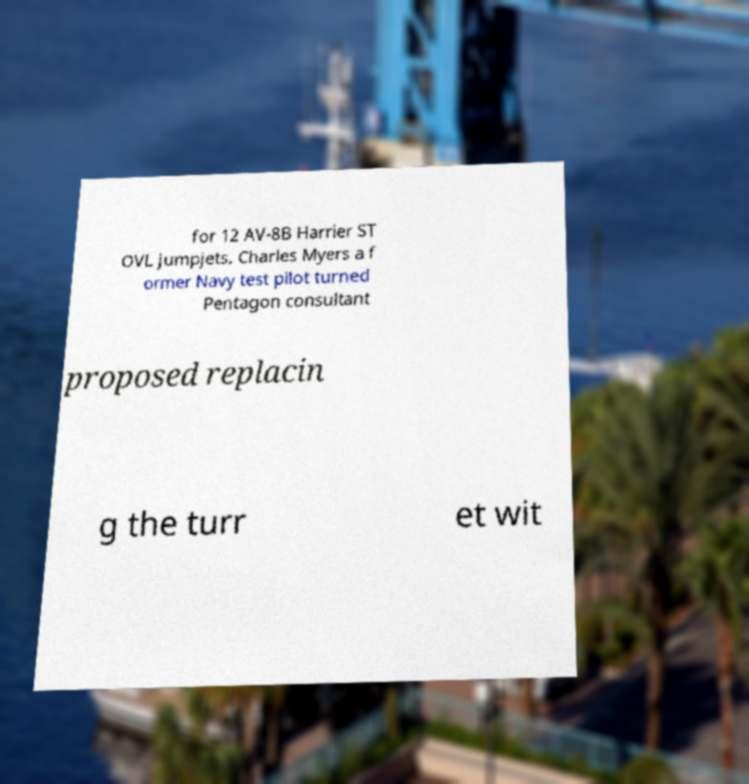Can you read and provide the text displayed in the image?This photo seems to have some interesting text. Can you extract and type it out for me? for 12 AV-8B Harrier ST OVL jumpjets. Charles Myers a f ormer Navy test pilot turned Pentagon consultant proposed replacin g the turr et wit 